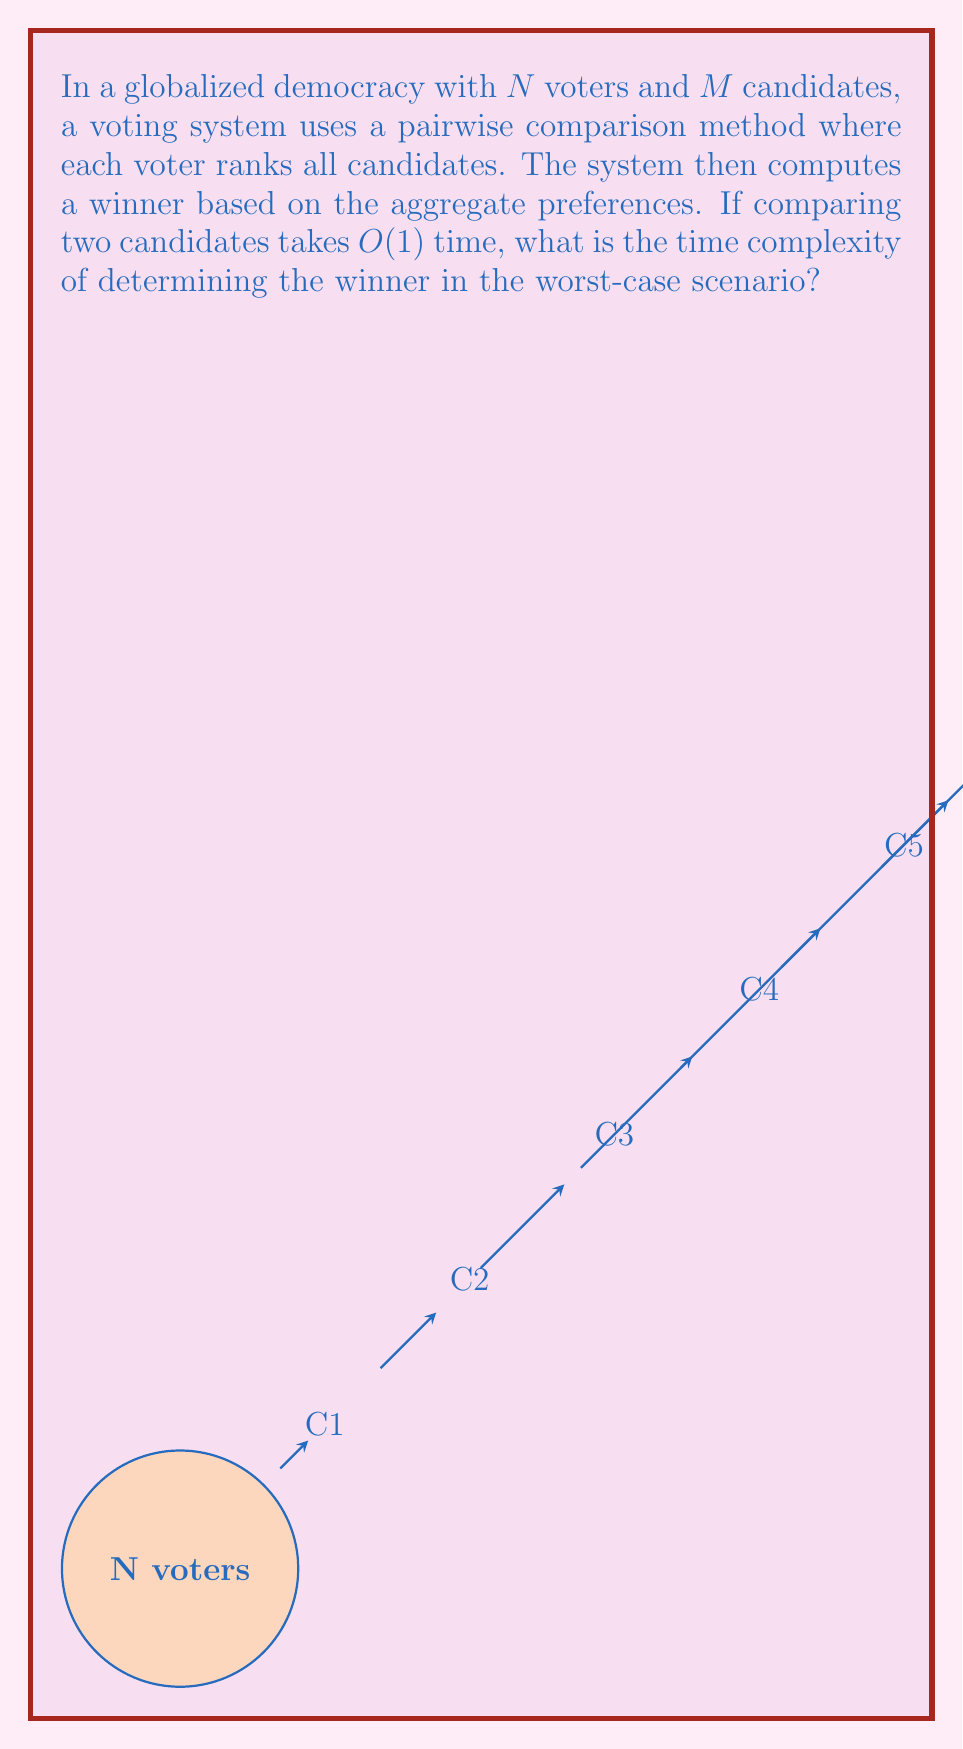Can you solve this math problem? Let's break this down step-by-step:

1) First, we need to consider how many pairwise comparisons are needed:
   - For each voter, we need to compare every candidate with every other candidate.
   - The number of pairwise comparisons for one voter is $\binom{M}{2} = \frac{M(M-1)}{2}$.

2) We need to do this for all $N$ voters, so the total number of comparisons is:
   $$N \cdot \frac{M(M-1)}{2}$$

3) Each comparison takes $O(1)$ time, so the time to collect all preferences is:
   $$O(N \cdot M^2)$$

4) After collecting preferences, we need to aggregate them. In the worst case, we might need to compare every pair of candidates again, which is $\binom{M}{2} = \frac{M(M-1)}{2}$ comparisons.

5) For each of these comparisons, we might need to look at the preferences of all $N$ voters.

6) Therefore, the aggregation step has a time complexity of:
   $$O(N \cdot M^2)$$

7) The total time complexity is the sum of the preference collection and aggregation steps, which is:
   $$O(N \cdot M^2) + O(N \cdot M^2) = O(N \cdot M^2)$$

This quadratic complexity in terms of the number of candidates demonstrates why large-scale elections with many candidates can be computationally challenging, especially in a globalized context where the number of voters ($N$) can be very large.
Answer: $O(N \cdot M^2)$ 